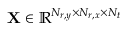<formula> <loc_0><loc_0><loc_500><loc_500>X \in \mathbb { R } ^ { N _ { r , y } \times N _ { r , x } \times N _ { t } }</formula> 